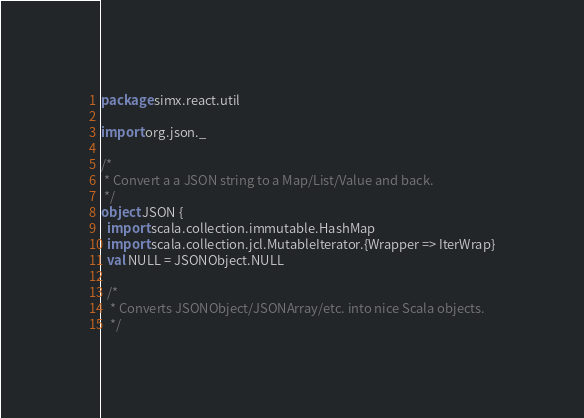<code> <loc_0><loc_0><loc_500><loc_500><_Scala_>package simx.react.util

import org.json._

/*
 * Convert a a JSON string to a Map/List/Value and back.
 */
object JSON {
  import scala.collection.immutable.HashMap
  import scala.collection.jcl.MutableIterator.{Wrapper => IterWrap}
  val NULL = JSONObject.NULL
  
  /*
   * Converts JSONObject/JSONArray/etc. into nice Scala objects.
   */</code> 